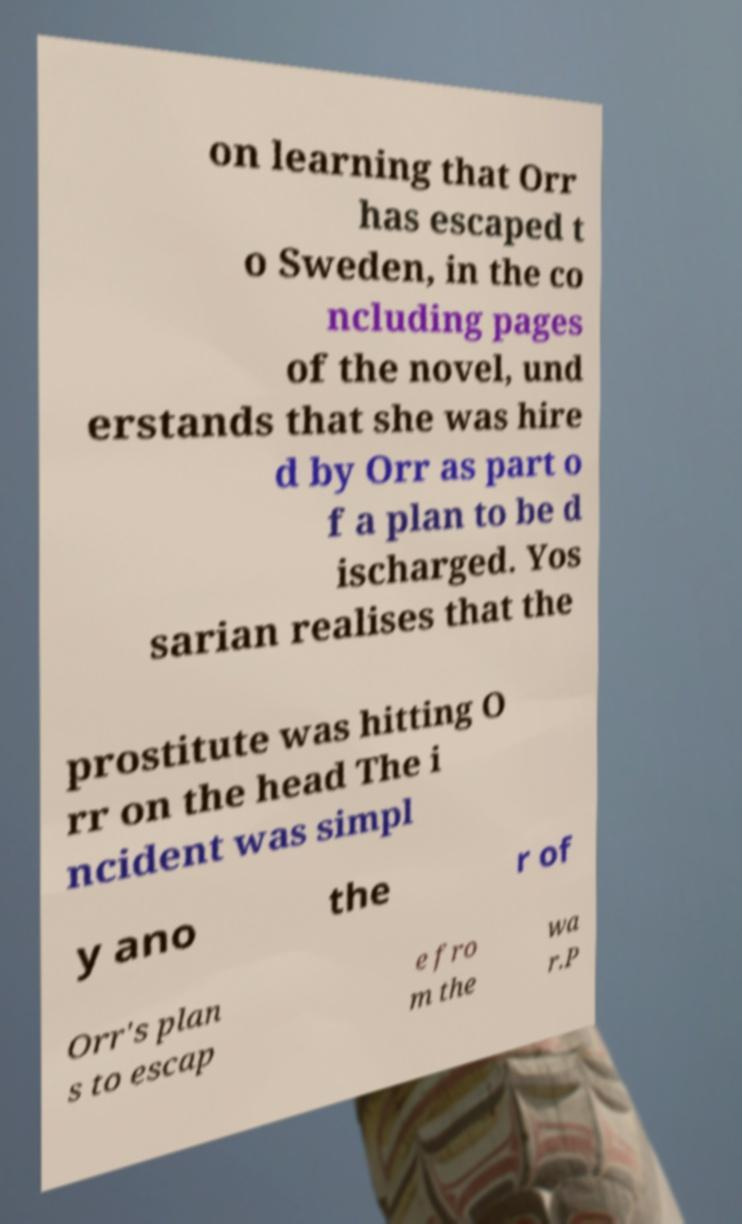I need the written content from this picture converted into text. Can you do that? on learning that Orr has escaped t o Sweden, in the co ncluding pages of the novel, und erstands that she was hire d by Orr as part o f a plan to be d ischarged. Yos sarian realises that the prostitute was hitting O rr on the head The i ncident was simpl y ano the r of Orr's plan s to escap e fro m the wa r.P 